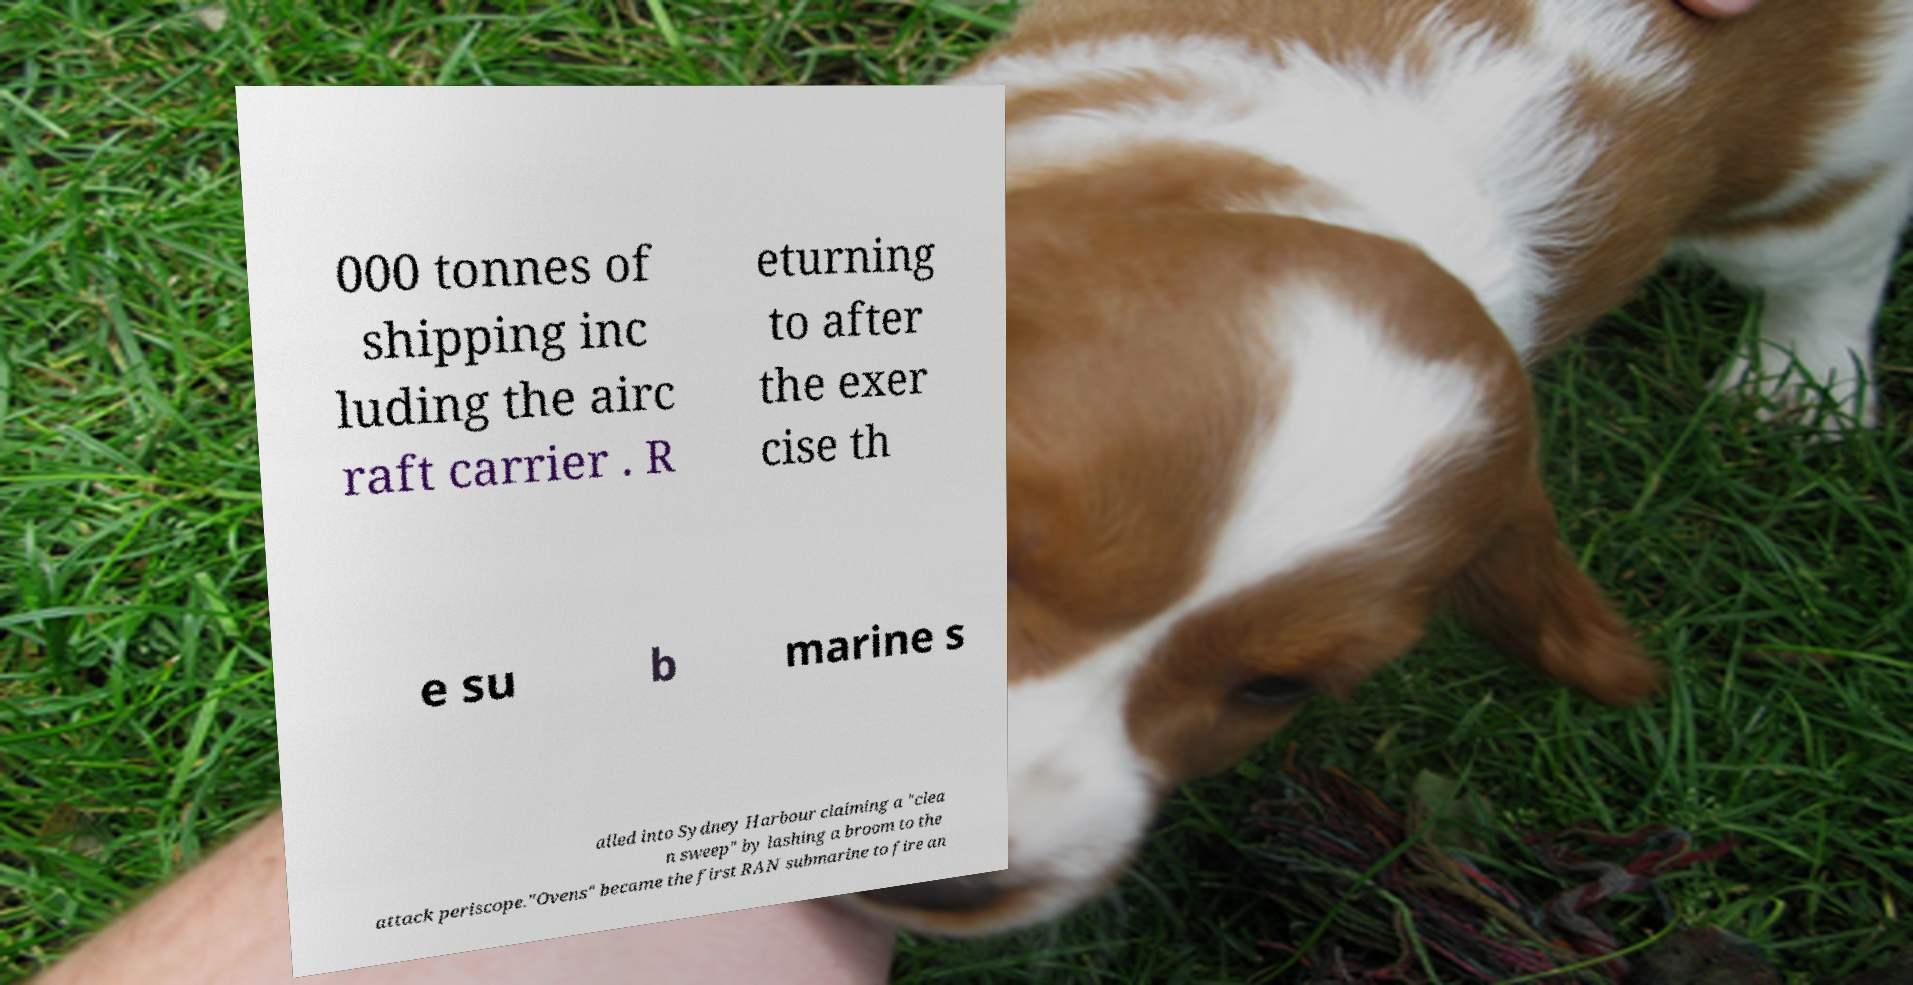Can you read and provide the text displayed in the image?This photo seems to have some interesting text. Can you extract and type it out for me? 000 tonnes of shipping inc luding the airc raft carrier . R eturning to after the exer cise th e su b marine s ailed into Sydney Harbour claiming a "clea n sweep" by lashing a broom to the attack periscope."Ovens" became the first RAN submarine to fire an 